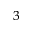<formula> <loc_0><loc_0><loc_500><loc_500>^ { 3 }</formula> 